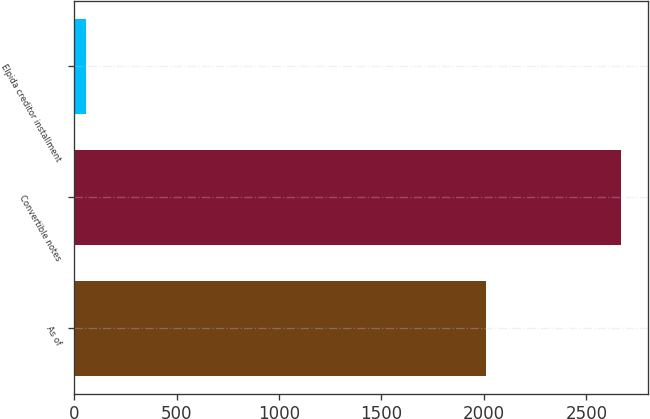Convert chart to OTSL. <chart><loc_0><loc_0><loc_500><loc_500><bar_chart><fcel>As of<fcel>Convertible notes<fcel>Elpida creditor installment<nl><fcel>2012<fcel>2669<fcel>56<nl></chart> 